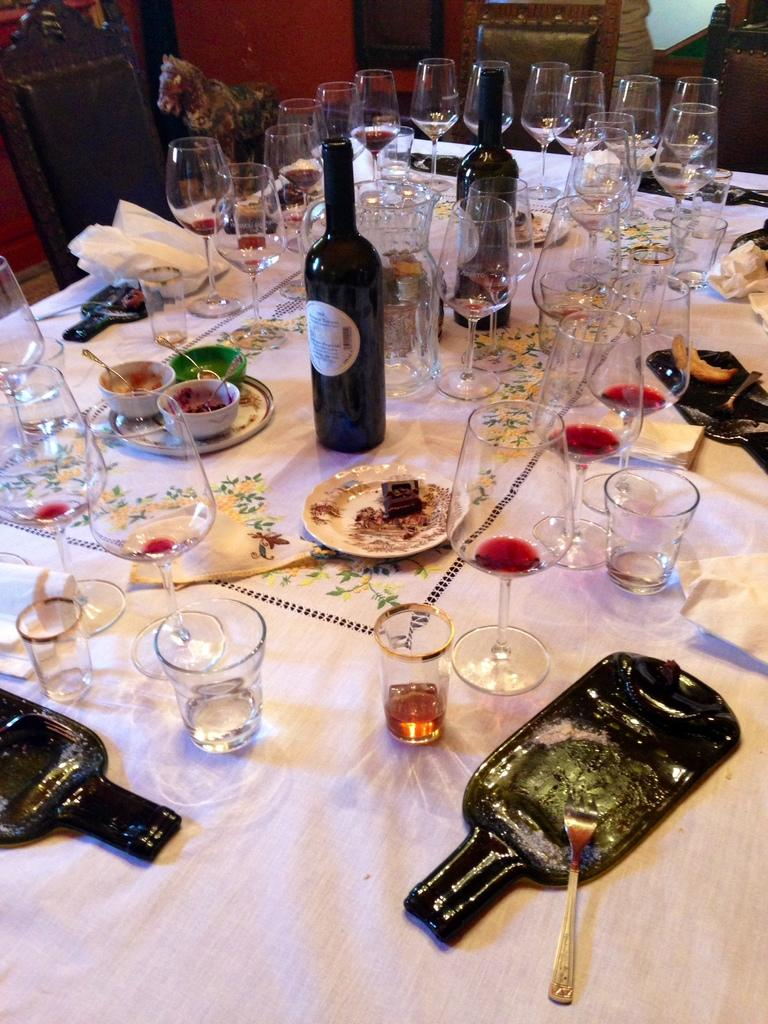What type of furniture is present in the image? There is a table in the image. What is placed on the table? On the table, there is a plate, glasses, bottles, and tissues. Are there any other food items on the table? Yes, there are other food items on the table. How many chairs are around the table? There are chairs around the table. What type of lettuce is used as a decoration on the cake in the image? There is no cake present in the image, so there is no lettuce used as a decoration. 